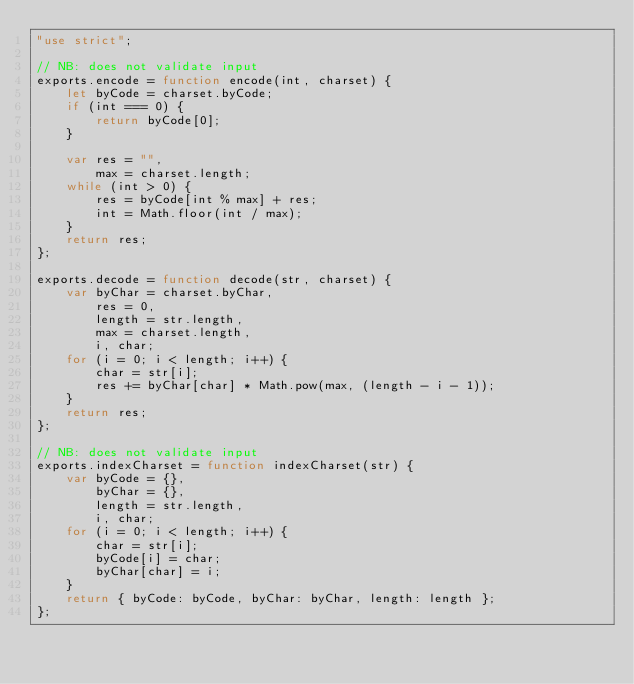Convert code to text. <code><loc_0><loc_0><loc_500><loc_500><_JavaScript_>"use strict";

// NB: does not validate input
exports.encode = function encode(int, charset) {
    let byCode = charset.byCode;
    if (int === 0) {
        return byCode[0];
    }

    var res = "",
        max = charset.length;
    while (int > 0) {
        res = byCode[int % max] + res;
        int = Math.floor(int / max);
    }
    return res;
};

exports.decode = function decode(str, charset) {
    var byChar = charset.byChar,
        res = 0,
        length = str.length,
        max = charset.length,
        i, char;
    for (i = 0; i < length; i++) {
        char = str[i];
        res += byChar[char] * Math.pow(max, (length - i - 1));
    }
    return res;
};

// NB: does not validate input
exports.indexCharset = function indexCharset(str) {
    var byCode = {},
        byChar = {},
        length = str.length,
        i, char;
    for (i = 0; i < length; i++) {
        char = str[i];
        byCode[i] = char;
        byChar[char] = i;
    }
    return { byCode: byCode, byChar: byChar, length: length };
};
</code> 